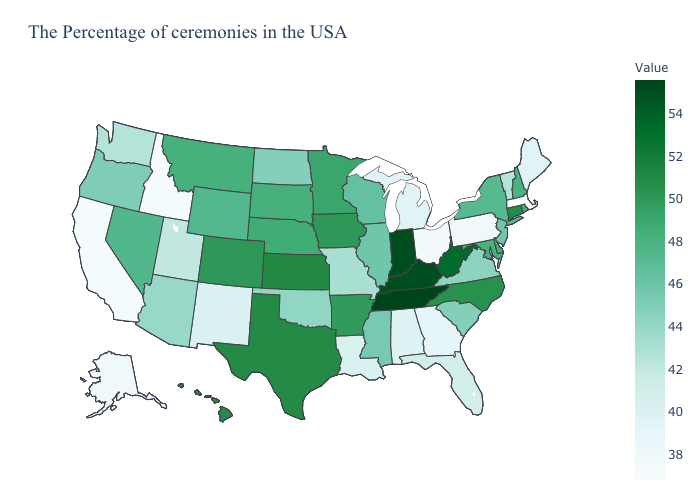Which states have the lowest value in the USA?
Concise answer only. Massachusetts. Does Tennessee have the highest value in the USA?
Short answer required. Yes. Among the states that border Virginia , does Maryland have the highest value?
Short answer required. No. Does Tennessee have the highest value in the USA?
Keep it brief. Yes. Which states have the lowest value in the USA?
Be succinct. Massachusetts. Does the map have missing data?
Give a very brief answer. No. Is the legend a continuous bar?
Be succinct. Yes. 